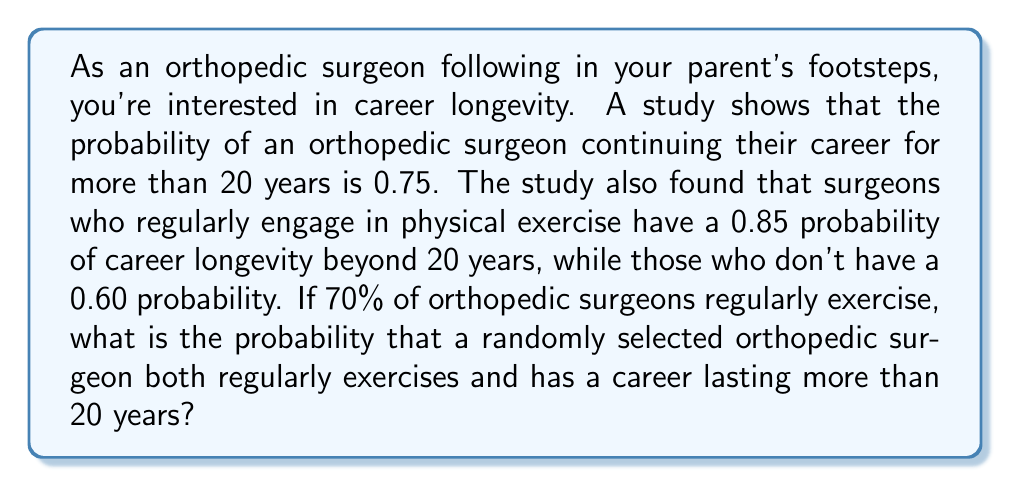Help me with this question. To solve this problem, we'll use the concept of conditional probability and the law of total probability. Let's define our events:

A: The surgeon has a career lasting more than 20 years
B: The surgeon regularly exercises

Given:
P(A) = 0.75
P(A|B) = 0.85 (probability of career longevity given that the surgeon exercises)
P(A|not B) = 0.60 (probability of career longevity given that the surgeon doesn't exercise)
P(B) = 0.70 (70% of surgeons exercise regularly)

We want to find P(A and B), which is the probability that a surgeon both exercises regularly and has a career lasting more than 20 years.

We can use the formula:
$$P(A \text{ and } B) = P(B) \cdot P(A|B)$$

Plugging in the values:
$$P(A \text{ and } B) = 0.70 \cdot 0.85 = 0.595$$

To verify this result, we can use the law of total probability:
$$P(A) = P(B) \cdot P(A|B) + P(\text{not } B) \cdot P(A|\text{not } B)$$

$$0.75 = 0.70 \cdot 0.85 + 0.30 \cdot 0.60$$
$$0.75 = 0.595 + 0.18 = 0.775$$

The slight discrepancy (0.775 vs 0.75) is due to rounding in the given probabilities.
Answer: The probability that a randomly selected orthopedic surgeon both regularly exercises and has a career lasting more than 20 years is 0.595 or approximately 59.5%. 